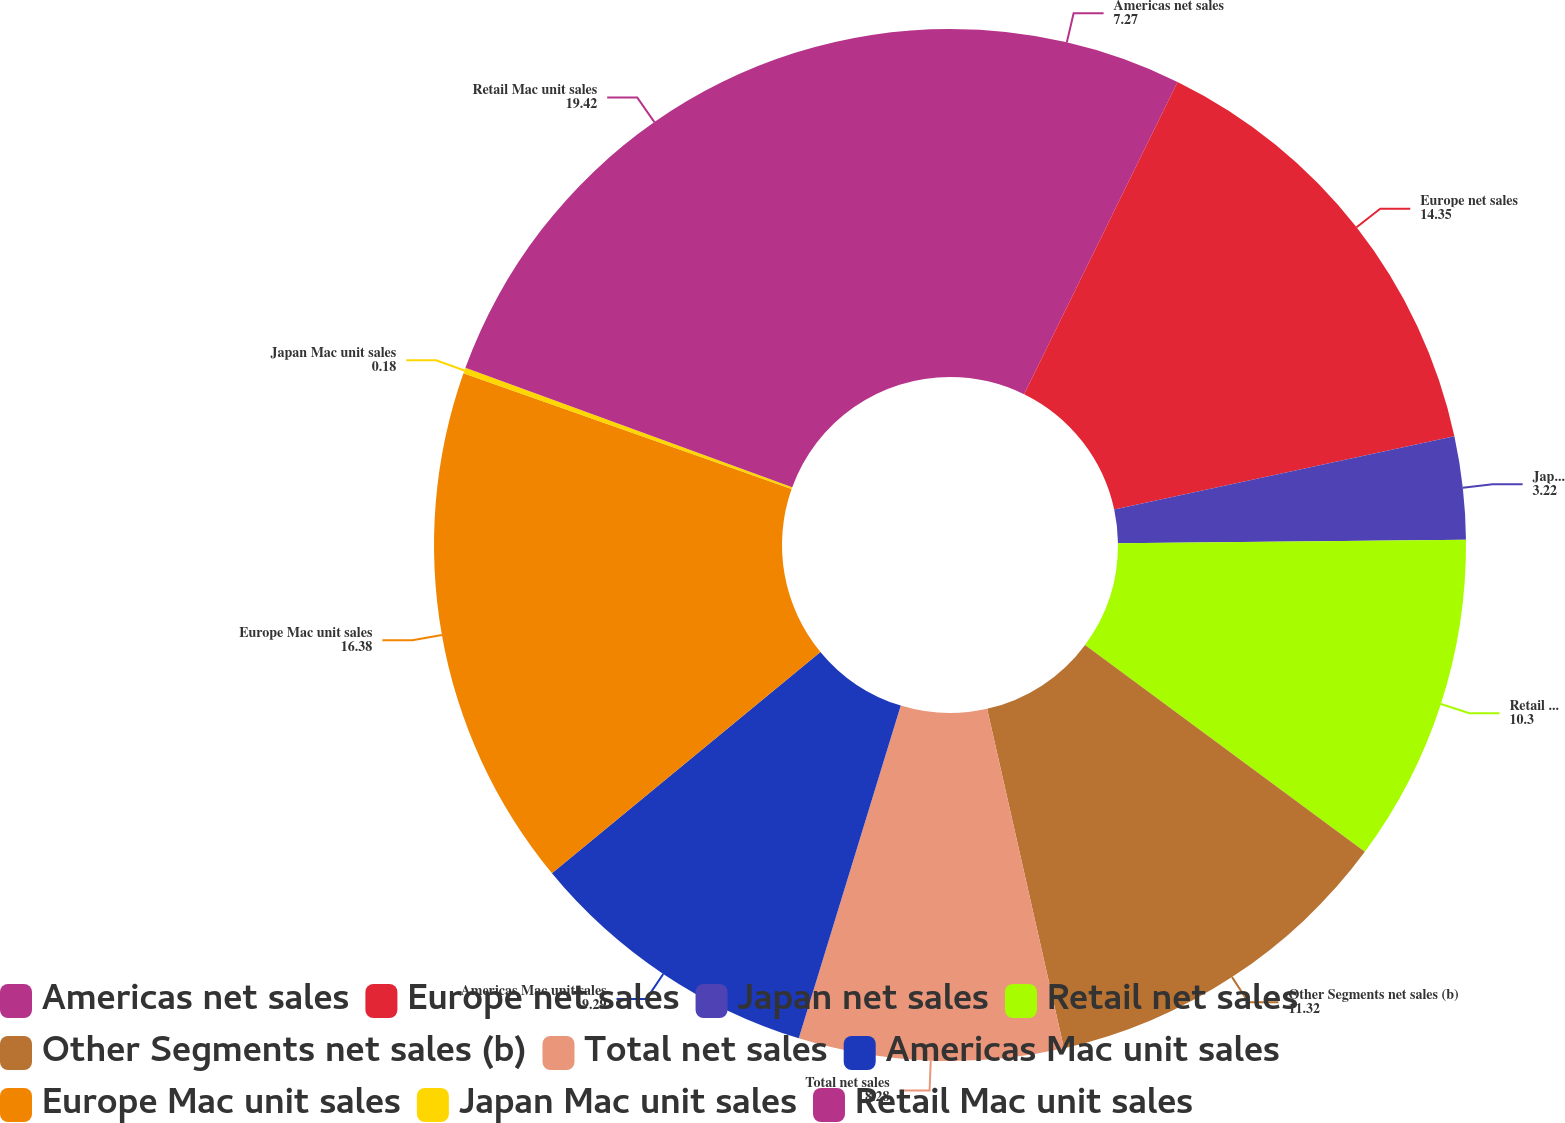Convert chart. <chart><loc_0><loc_0><loc_500><loc_500><pie_chart><fcel>Americas net sales<fcel>Europe net sales<fcel>Japan net sales<fcel>Retail net sales<fcel>Other Segments net sales (b)<fcel>Total net sales<fcel>Americas Mac unit sales<fcel>Europe Mac unit sales<fcel>Japan Mac unit sales<fcel>Retail Mac unit sales<nl><fcel>7.27%<fcel>14.35%<fcel>3.22%<fcel>10.3%<fcel>11.32%<fcel>8.28%<fcel>9.29%<fcel>16.38%<fcel>0.18%<fcel>19.42%<nl></chart> 